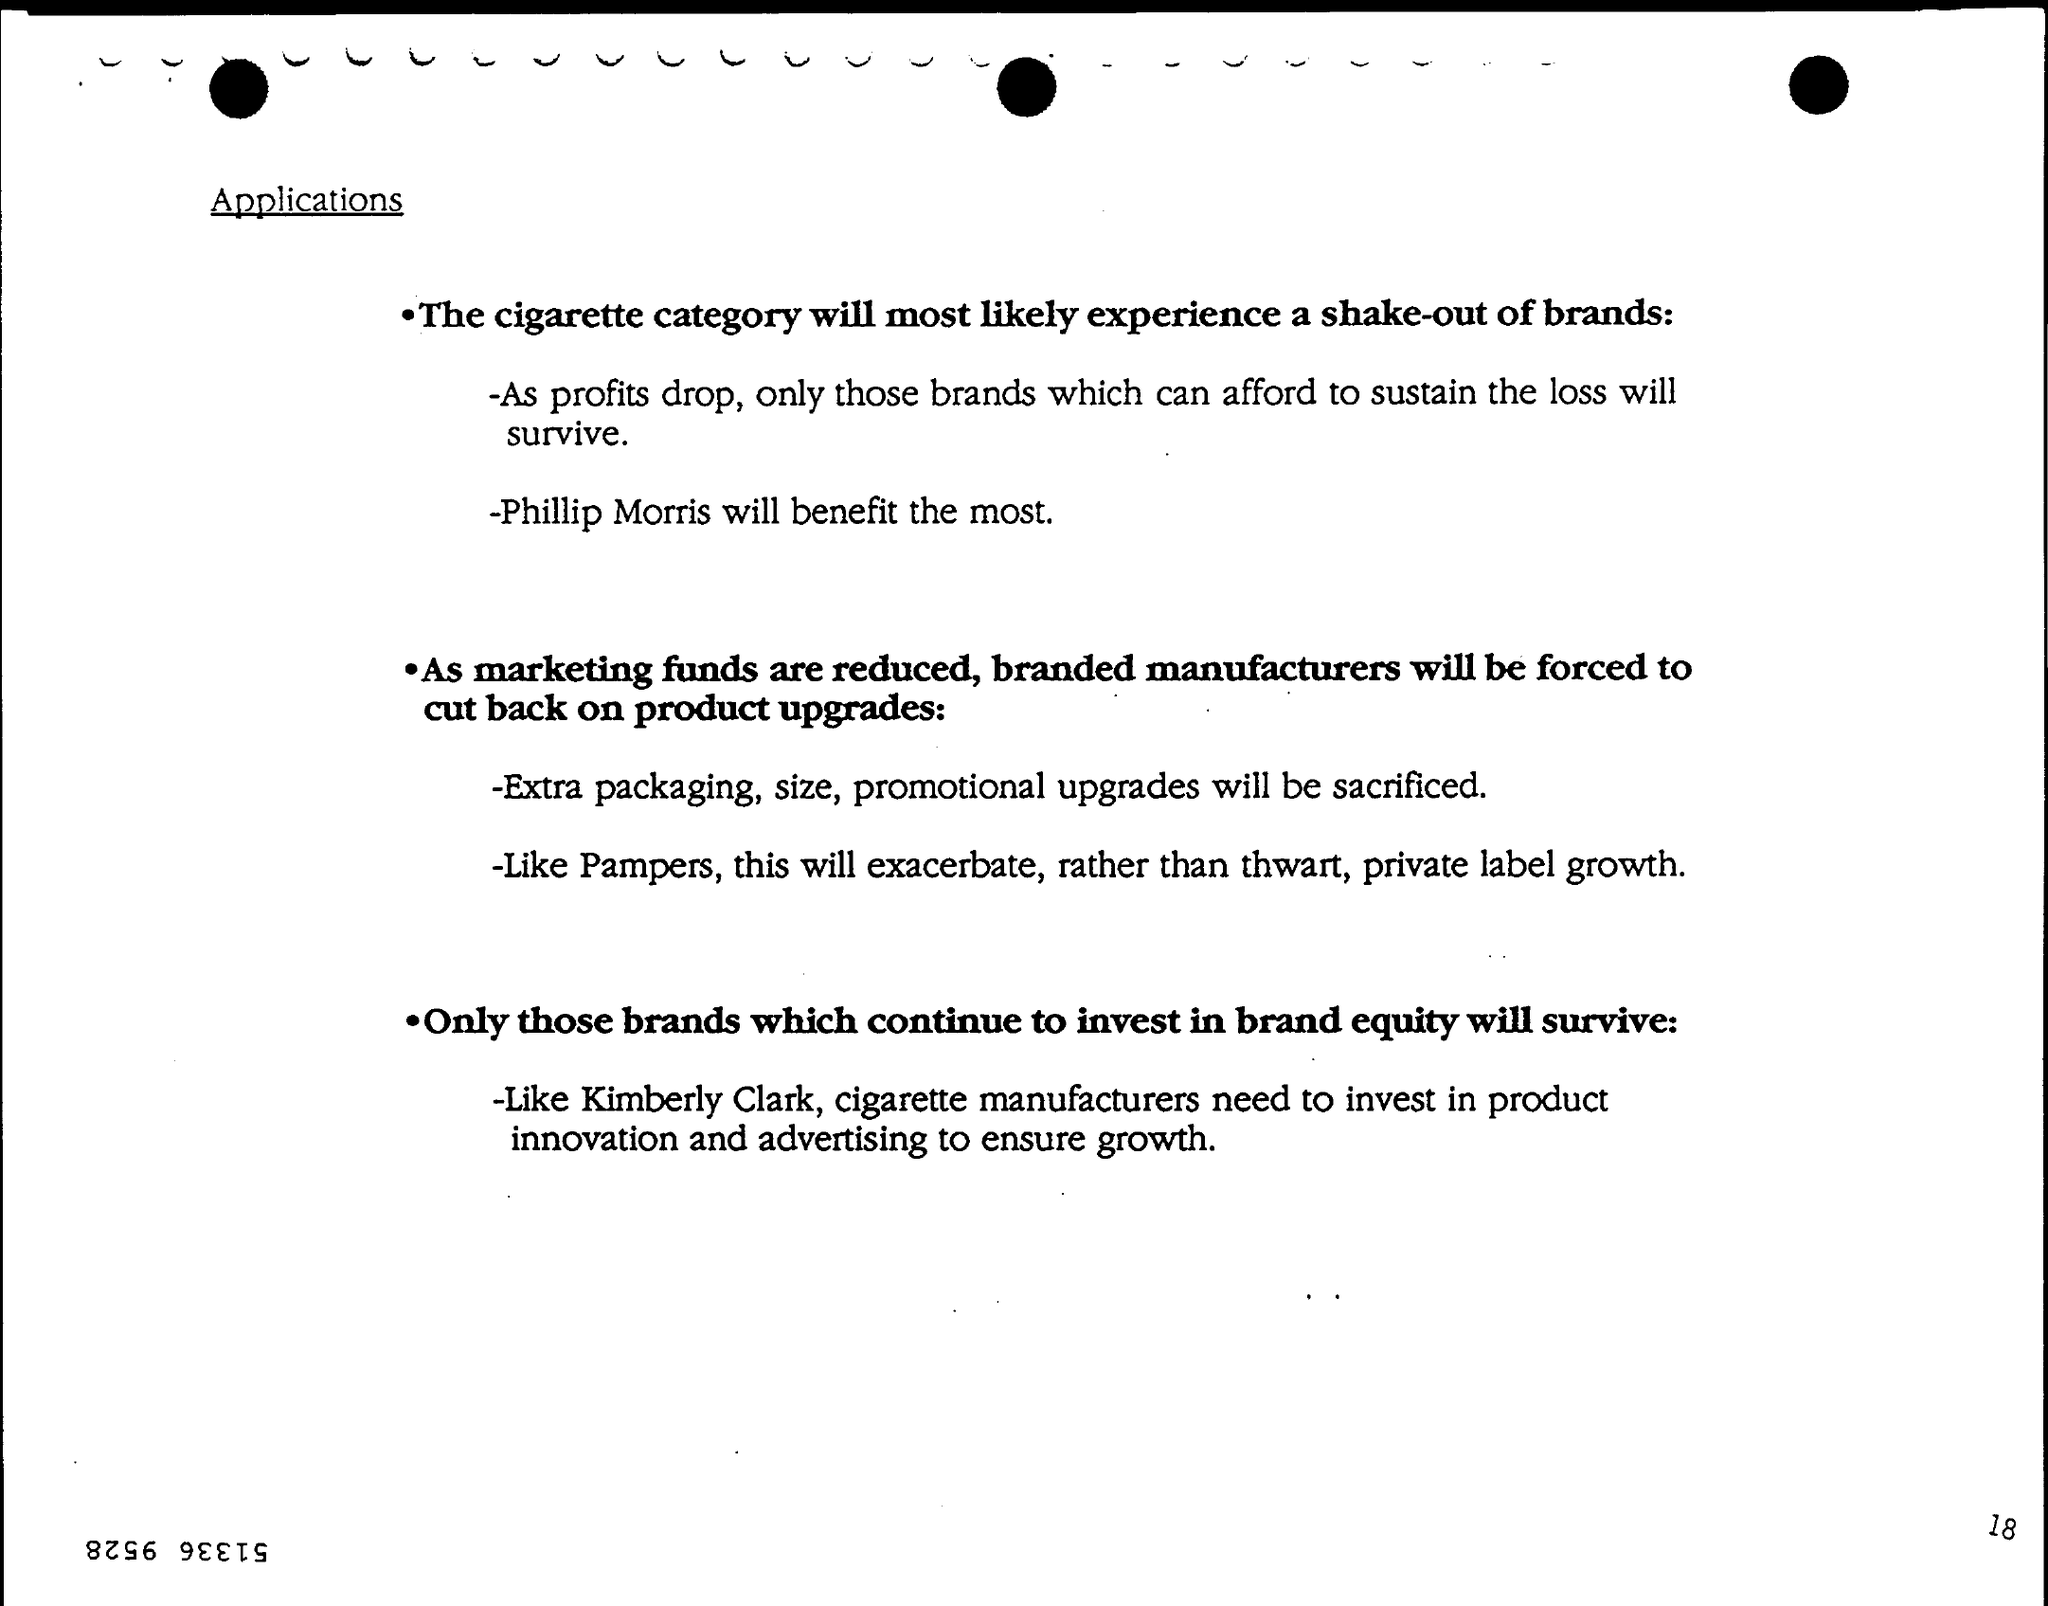Mention a couple of crucial points in this snapshot. It is evident that Kimberly Clark invests in brand equity, as it is a well-known brand that has established a strong reputation and positive image among its target audience. As a result of reduced marketing funds, certain product upgrades will need to be sacrificed in order to allocate the necessary resources to other areas. This may include downgrading the packaging, size, or promotional elements of the product. The outcome that will be most beneficial for Phillip Morris is... 